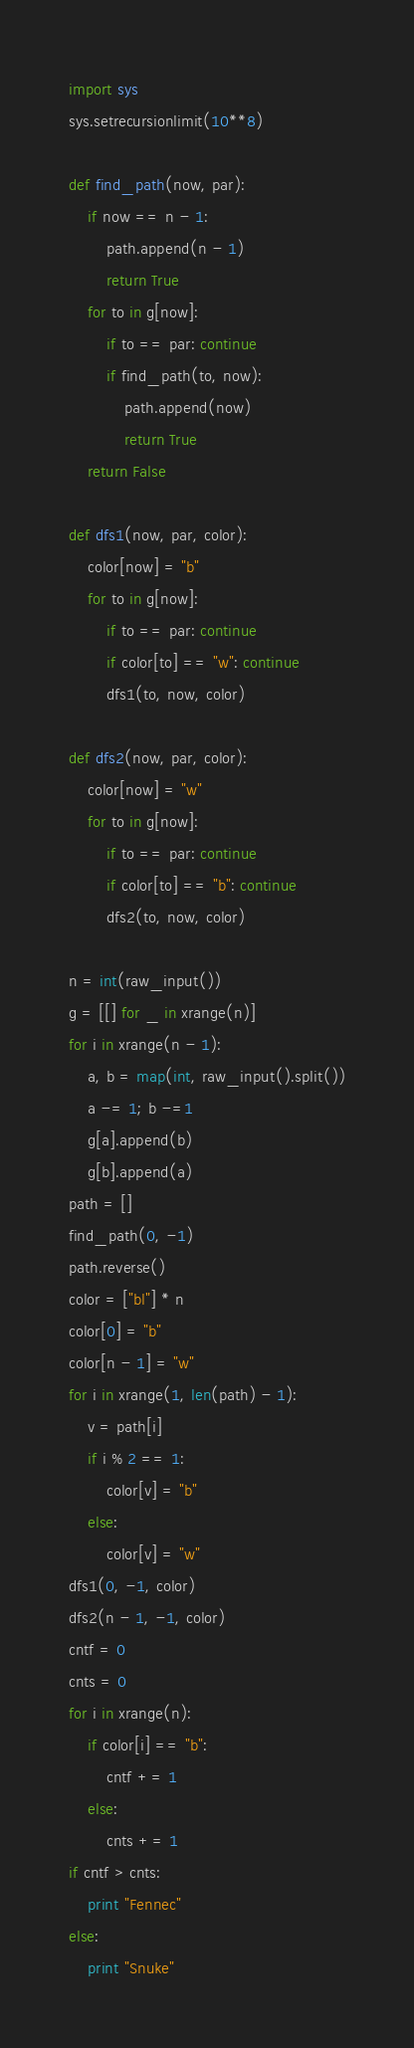Convert code to text. <code><loc_0><loc_0><loc_500><loc_500><_Python_>import sys
sys.setrecursionlimit(10**8)

def find_path(now, par):
    if now == n - 1:
        path.append(n - 1)
        return True
    for to in g[now]:
        if to == par: continue
        if find_path(to, now):
            path.append(now)
            return True
    return False

def dfs1(now, par, color):
    color[now] = "b"
    for to in g[now]:
        if to == par: continue
        if color[to] == "w": continue
        dfs1(to, now, color)

def dfs2(now, par, color):
    color[now] = "w"
    for to in g[now]:
        if to == par: continue
        if color[to] == "b": continue
        dfs2(to, now, color)

n = int(raw_input())
g = [[] for _ in xrange(n)]
for i in xrange(n - 1):
    a, b = map(int, raw_input().split())
    a -= 1; b -=1
    g[a].append(b)
    g[b].append(a)
path = []
find_path(0, -1)
path.reverse()
color = ["bl"] * n
color[0] = "b"
color[n - 1] = "w"
for i in xrange(1, len(path) - 1):
    v = path[i]
    if i % 2 == 1:
        color[v] = "b"
    else:
        color[v] = "w"
dfs1(0, -1, color)
dfs2(n - 1, -1, color)
cntf = 0
cnts = 0
for i in xrange(n):
    if color[i] == "b":
        cntf += 1
    else:
        cnts += 1
if cntf > cnts:
    print "Fennec"
else:
    print "Snuke"
</code> 